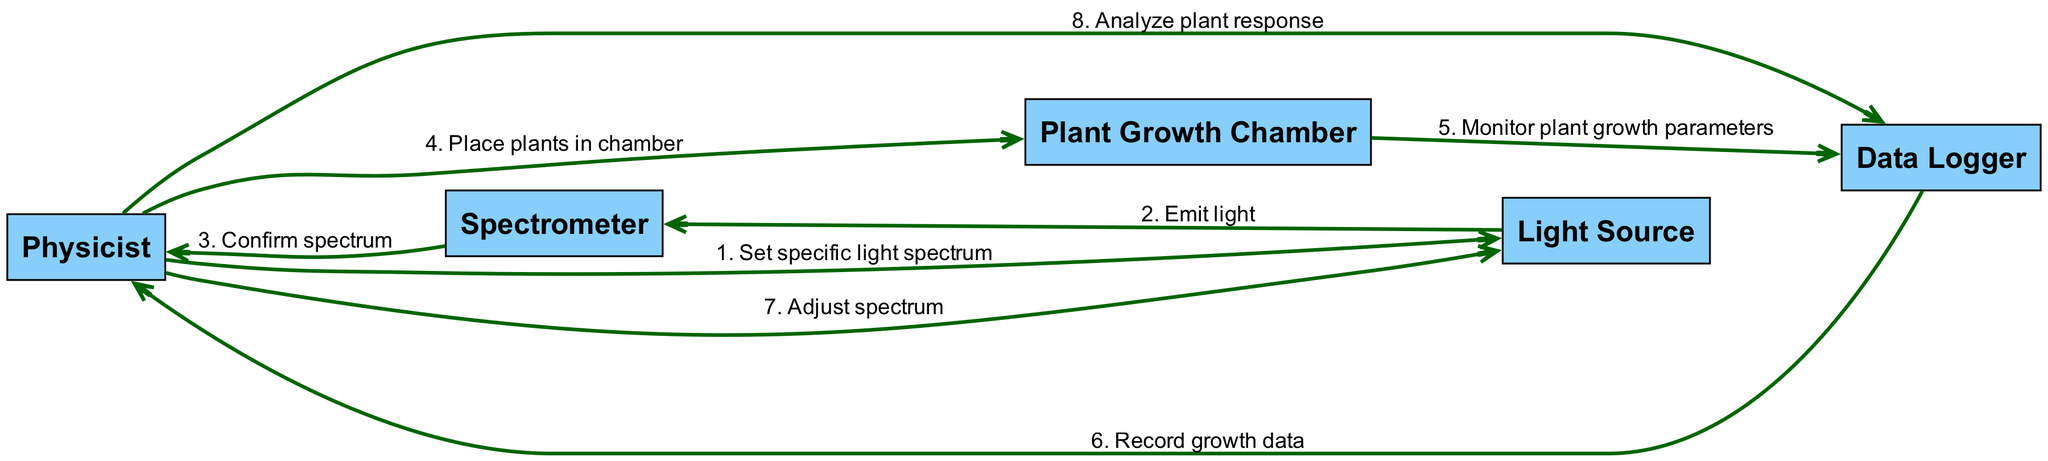What is the first message sent by the physicist? The first message in the sequence diagram is sent from the Physicist to the Light Source, which is "Set specific light spectrum."
Answer: Set specific light spectrum How many actors are involved in the experiment? The diagram lists five actors: Physicist, Spectrometer, Plant Growth Chamber, Light Source, and Data Logger.
Answer: Five Which actor confirms the spectrum? The Spectrometer is the actor that sends back the confirmation of the spectrum to the Physicist.
Answer: Spectrometer What action follows after monitoring plant growth parameters? After monitoring plant growth parameters, the next action is for the Data Logger to record growth data and send that back to the Physicist.
Answer: Record growth data What is the last action taken by the physicist? The last action taken by the Physicist is "Analyze plant response," which is done after adjusting the light spectrum.
Answer: Analyze plant response Which actor is responsible for emitting light? The Light Source is responsible for emitting light after being set by the Physicist.
Answer: Light Source How many steps are taken to adjust the light spectrum? There is one step specifically mentioned in the sequence where the Physicist adjusts the spectrum.
Answer: One Between which two actors is the message "Monitor plant growth parameters" sent? The message is sent from the Plant Growth Chamber to the Data Logger.
Answer: Plant Growth Chamber and Data Logger What occurs immediately after the Data Logger records growth data? There is no additional action mentioned immediately after the Data Logger records growth data; it follows with the Physicist then adjusting the spectrum.
Answer: None 